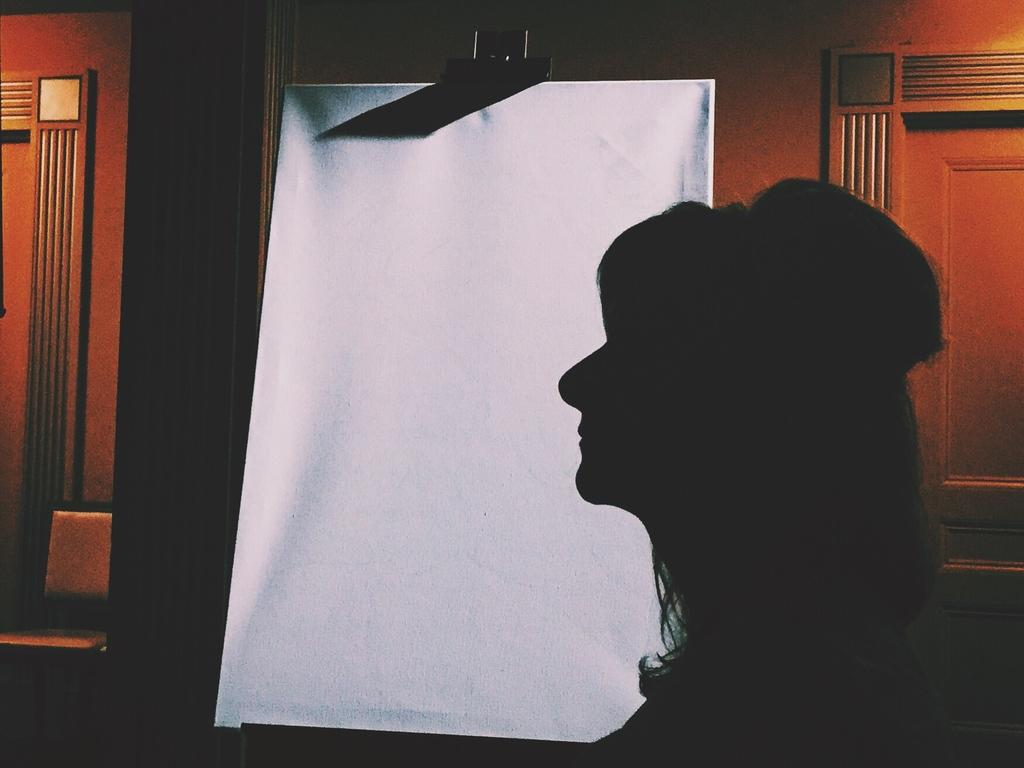What is the main subject of the image? There is a person in the image. What object is present in the image that might be used for writing or displaying information? There is a whiteboard in the image. What type of wall can be seen in the background of the image? There is a wooden wall in the background of the image. What is the plot of the story being told on the whiteboard in the image? There is no story being told on the whiteboard in the image; it is just a plain whiteboard. How many uncles are present in the image? There are no uncles present in the image. 